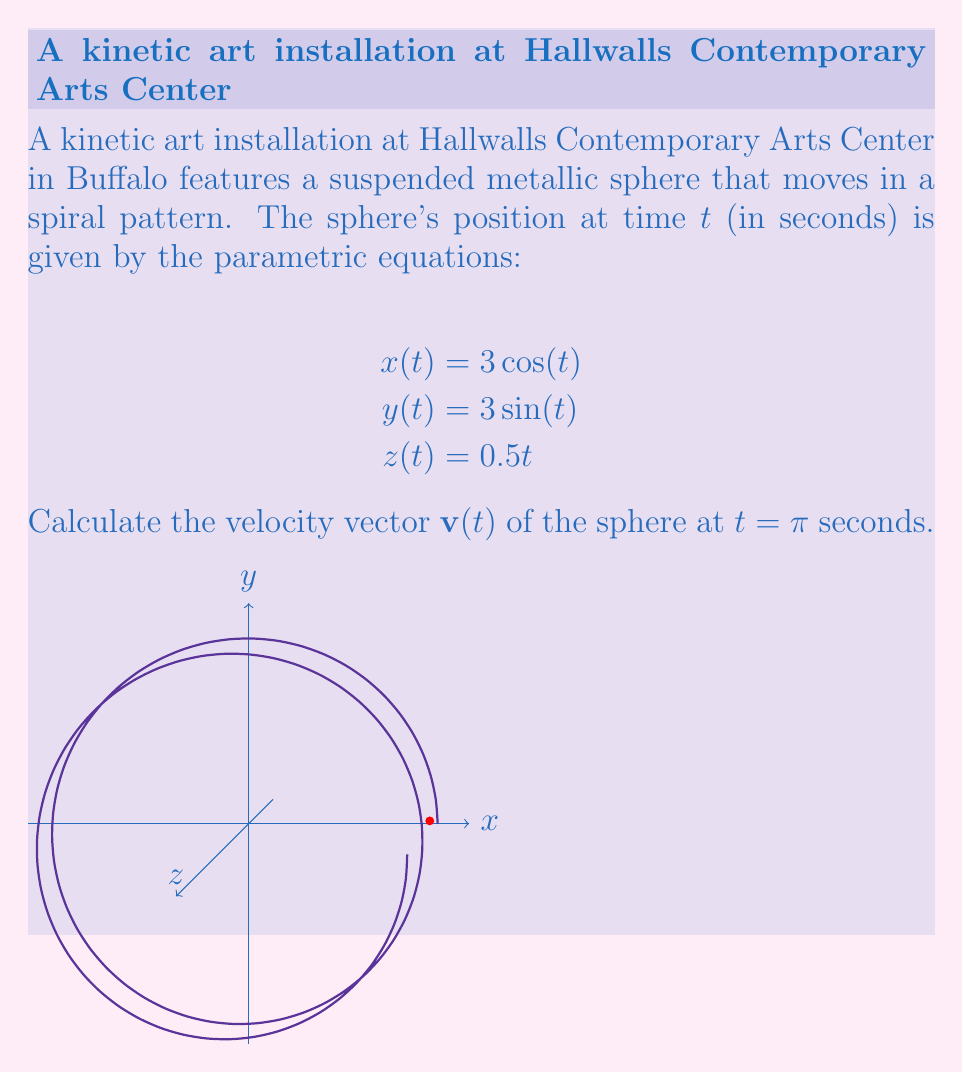Could you help me with this problem? To find the velocity vector $\mathbf{v}(t)$, we need to differentiate each component of the position vector with respect to time:

1) First, let's find the components of the velocity vector:

   $$v_x(t) = \frac{dx}{dt} = -3\sin(t)$$
   $$v_y(t) = \frac{dy}{dt} = 3\cos(t)$$
   $$v_z(t) = \frac{dz}{dt} = 0.5$$

2) The velocity vector is therefore:

   $$\mathbf{v}(t) = \langle -3\sin(t), 3\cos(t), 0.5 \rangle$$

3) Now, we need to evaluate this at $t = \pi$:

   $$\mathbf{v}(\pi) = \langle -3\sin(\pi), 3\cos(\pi), 0.5 \rangle$$

4) Simplify:
   - $\sin(\pi) = 0$
   - $\cos(\pi) = -1$

5) Therefore:

   $$\mathbf{v}(\pi) = \langle 0, -3, 0.5 \rangle$$

This vector represents the instantaneous velocity of the sphere at $t = \pi$ seconds.
Answer: $\mathbf{v}(\pi) = \langle 0, -3, 0.5 \rangle$ 